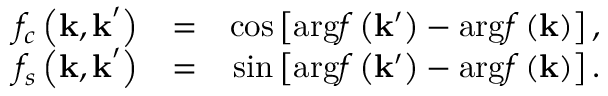Convert formula to latex. <formula><loc_0><loc_0><loc_500><loc_500>\begin{array} { r l r } { f _ { c } \left ( k , k ^ { \prime } \right ) } & { = } & { \cos \left [ \arg f \left ( k ^ { \prime } \right ) - \arg f \left ( k \right ) \right ] , } \\ { f _ { s } \left ( k , k ^ { \prime } \right ) } & { = } & { \sin \left [ \arg f \left ( k ^ { \prime } \right ) - \arg f \left ( k \right ) \right ] . } \end{array}</formula> 